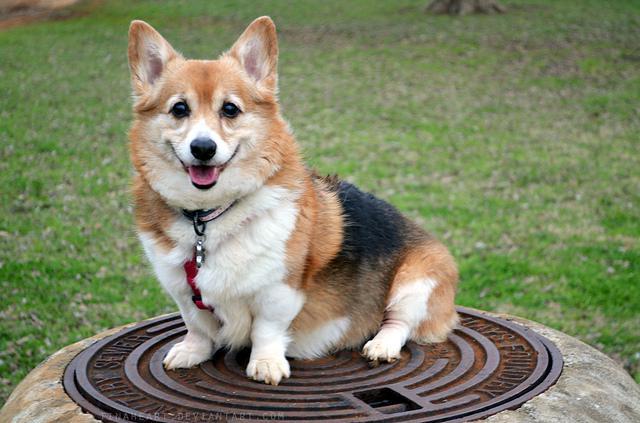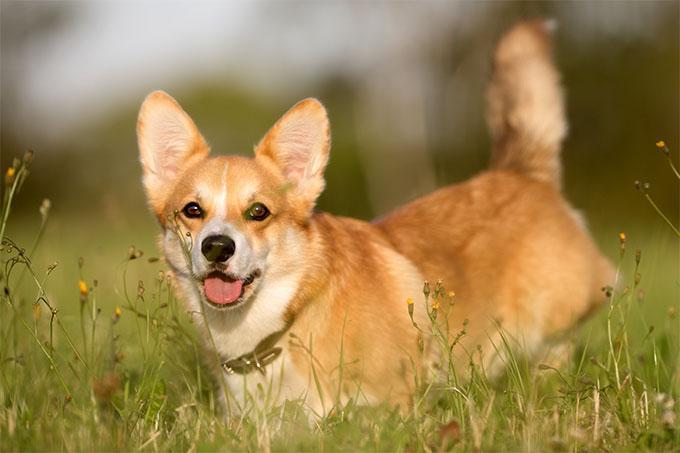The first image is the image on the left, the second image is the image on the right. For the images displayed, is the sentence "An image shows a corgi with body turned leftward on a white background." factually correct? Answer yes or no. No. The first image is the image on the left, the second image is the image on the right. Given the left and right images, does the statement "There are two dogs with tongue sticking out." hold true? Answer yes or no. Yes. 